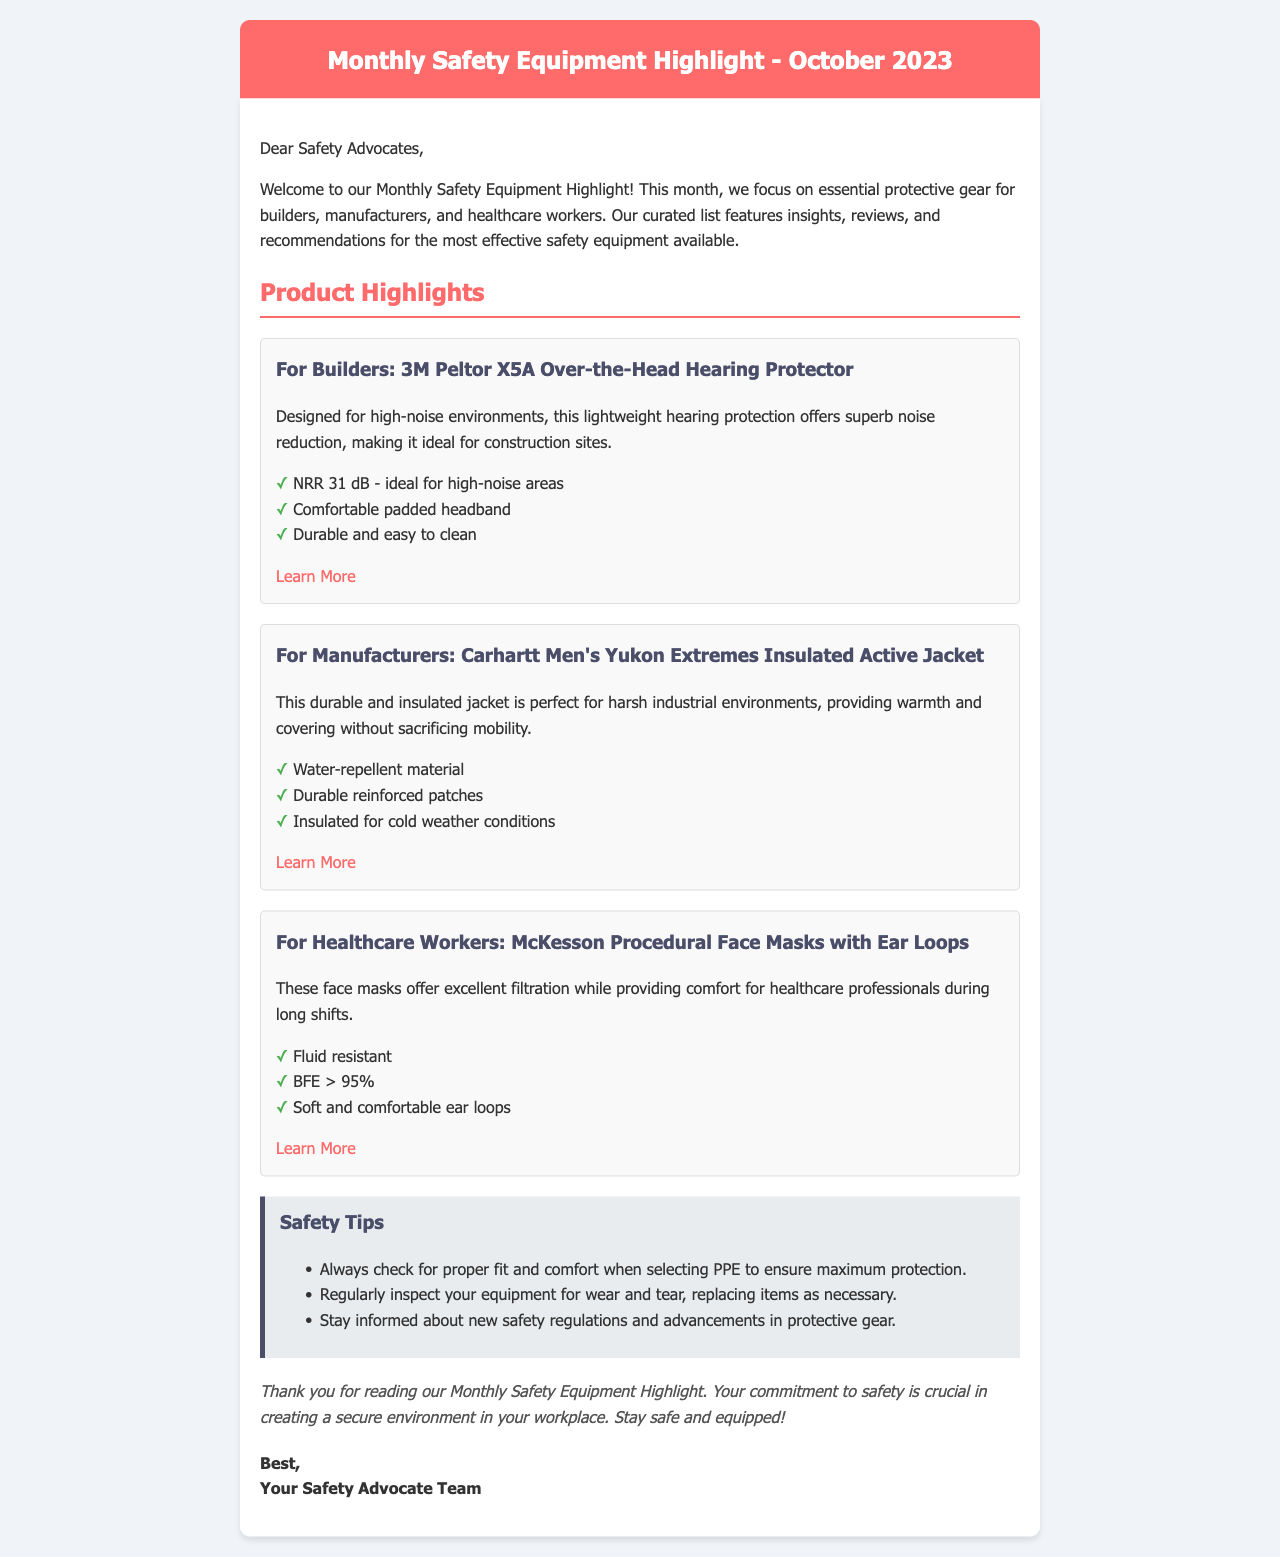What is the main focus of the newsletter? The newsletter focuses on essential protective gear for builders, manufacturers, and healthcare workers.
Answer: Protective gear What product is highlighted for builders? The product highlighted for builders is specifically mentioned in the document.
Answer: 3M Peltor X5A Over-the-Head Hearing Protector What is the NRR of the hearing protector? The NRR is a specific measurement mentioned for the hearing protector in the document.
Answer: 31 dB What type of jacket is recommended for manufacturers? The document mentions a specific type of jacket suitable for manufacturers.
Answer: Carhartt Men's Yukon Extremes Insulated Active Jacket What percentage of BFE do the healthcare masks achieve? The percentage of BFE is a key feature highlighted for the healthcare worker's product.
Answer: > 95% What is one of the safety tips provided in the newsletter? The newsletter includes specific safety tips which are listed in the document.
Answer: Always check for proper fit and comfort Who is the newsletter addressed to? The beginning of the newsletter specifies the audience it is addressing.
Answer: Safety Advocates What is the conclusion's emphasis in the email? The conclusion provides a specific message regarding safety commitment in the workplace.
Answer: Commitment to safety 